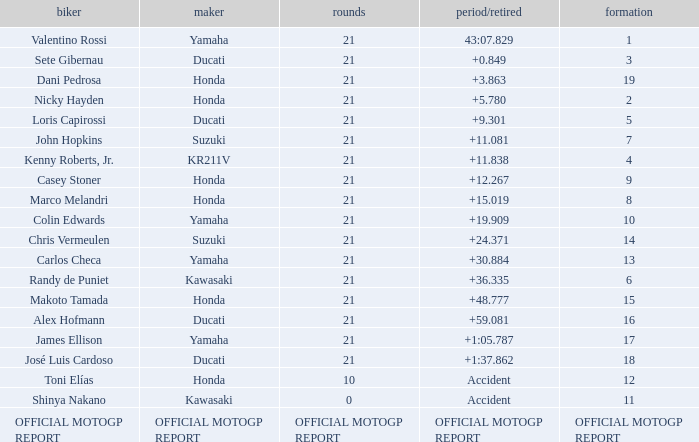How many laps did Valentino rossi have when riding a vehicle manufactured by yamaha? 21.0. 